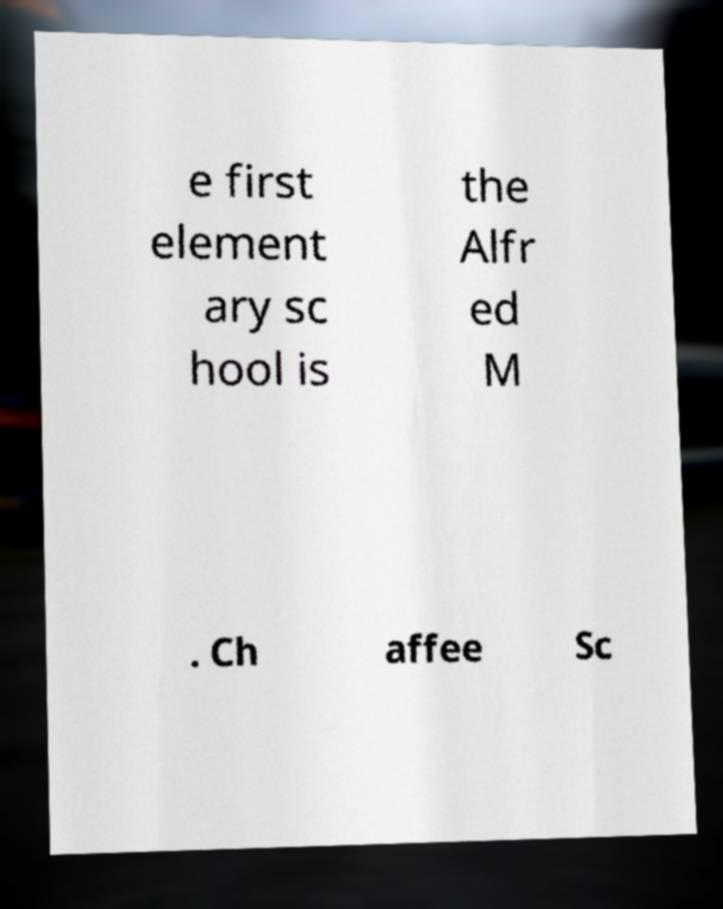Can you read and provide the text displayed in the image?This photo seems to have some interesting text. Can you extract and type it out for me? e first element ary sc hool is the Alfr ed M . Ch affee Sc 